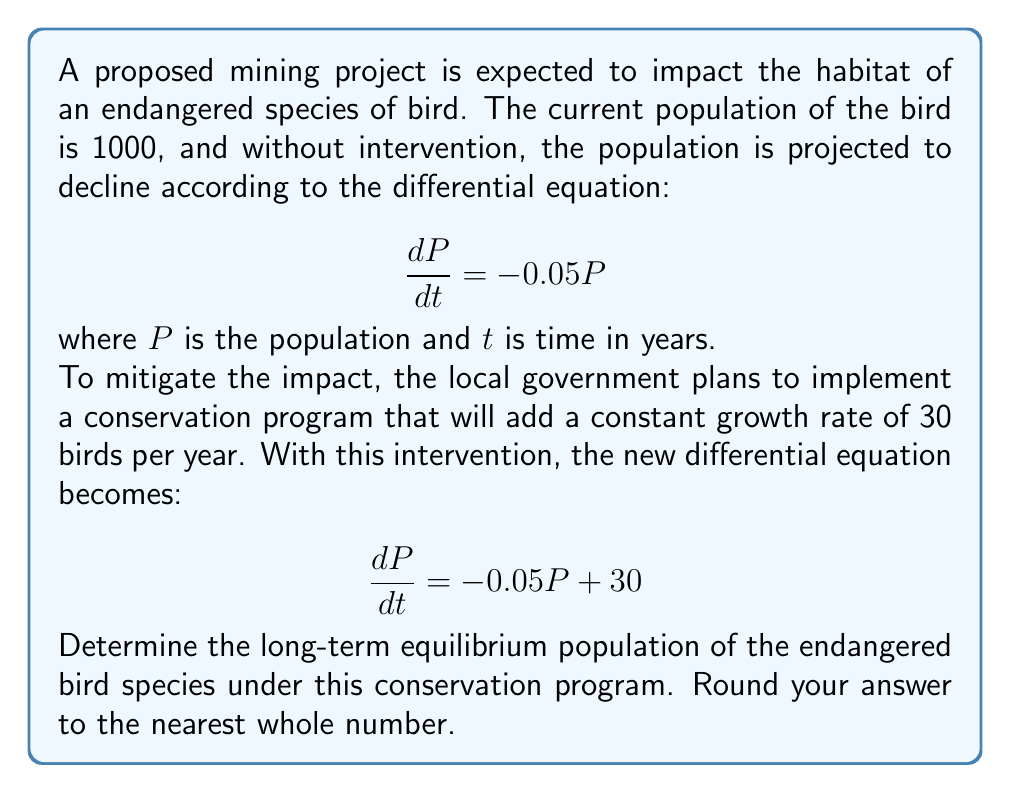Can you answer this question? To find the long-term equilibrium population, we need to solve for $P$ when $\frac{dP}{dt} = 0$. This is because, at equilibrium, the population is not changing over time.

Step 1: Set the differential equation equal to zero.
$$0 = -0.05P + 30$$

Step 2: Solve for P.
$$0.05P = 30$$
$$P = \frac{30}{0.05}$$
$$P = 600$$

Step 3: Interpret the result.
The equilibrium population is 600 birds. This means that over time, the population will stabilize at this level, where the natural decline due to habitat loss is exactly balanced by the conservation efforts.

Step 4: Round to the nearest whole number.
Since we're dealing with a population of birds, we need to round to the nearest whole number. In this case, 600 is already a whole number, so no rounding is necessary.
Answer: 600 birds 